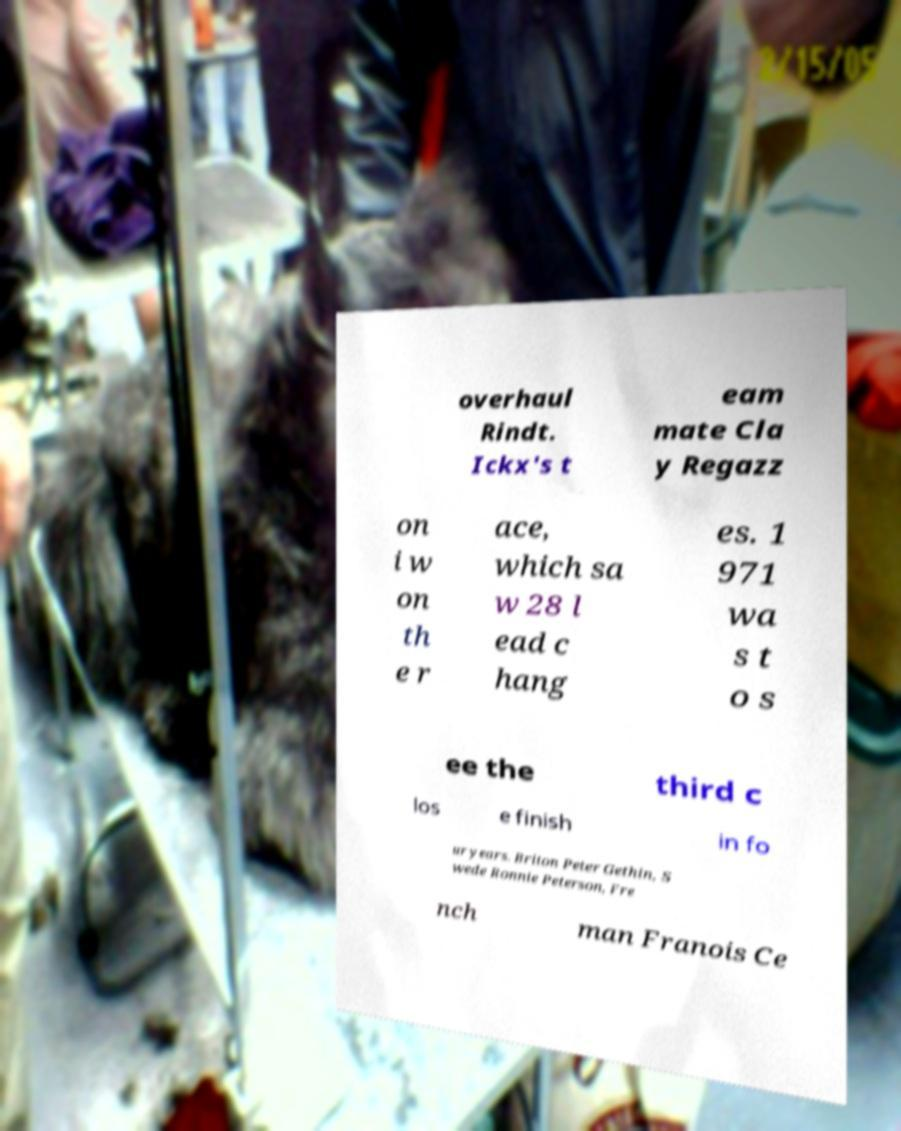There's text embedded in this image that I need extracted. Can you transcribe it verbatim? overhaul Rindt. Ickx's t eam mate Cla y Regazz on i w on th e r ace, which sa w 28 l ead c hang es. 1 971 wa s t o s ee the third c los e finish in fo ur years. Briton Peter Gethin, S wede Ronnie Peterson, Fre nch man Franois Ce 